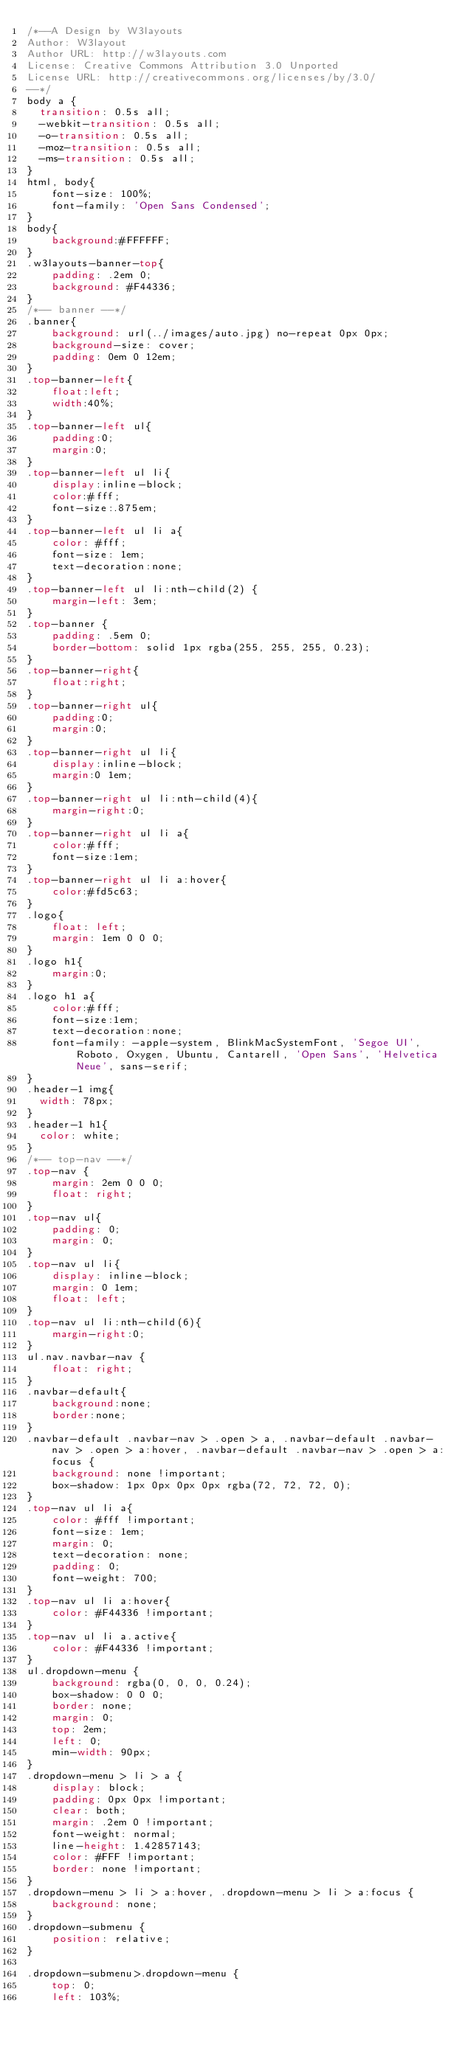Convert code to text. <code><loc_0><loc_0><loc_500><loc_500><_CSS_>/*--A Design by W3layouts 
Author: W3layout
Author URL: http://w3layouts.com
License: Creative Commons Attribution 3.0 Unported
License URL: http://creativecommons.org/licenses/by/3.0/
--*/
body a {
  transition: 0.5s all;
  -webkit-transition: 0.5s all;
  -o-transition: 0.5s all;
  -moz-transition: 0.5s all;
  -ms-transition: 0.5s all;
}
html, body{
    font-size: 100%;
	font-family: 'Open Sans Condensed';
}
body{
	background:#FFFFFF;
}
.w3layouts-banner-top{
    padding: .2em 0;
    background: #F44336;
}
/*-- banner --*/
.banner{
    background: url(../images/auto.jpg) no-repeat 0px 0px;
    background-size: cover;
    padding: 0em 0 12em;
}
.top-banner-left{
	float:left;
	width:40%;
}
.top-banner-left ul{
	padding:0;
	margin:0;
}
.top-banner-left ul li{
	display:inline-block;
	color:#fff;
	font-size:.875em;
}
.top-banner-left ul li a{
    color: #fff;
    font-size: 1em;
	text-decoration:none;
}
.top-banner-left ul li:nth-child(2) {
    margin-left: 3em;
}
.top-banner {
    padding: .5em 0;
    border-bottom: solid 1px rgba(255, 255, 255, 0.23);
}
.top-banner-right{
	float:right;
}
.top-banner-right ul{
	padding:0;
	margin:0;
}
.top-banner-right ul li{
	display:inline-block;
	margin:0 1em;
}
.top-banner-right ul li:nth-child(4){
	margin-right:0;
}
.top-banner-right ul li a{
	color:#fff;
	font-size:1em;
}
.top-banner-right ul li a:hover{
	color:#fd5c63;
}
.logo{
    float: left;
    margin: 1em 0 0 0;
}
.logo h1{
	margin:0;
}
.logo h1 a{
	color:#fff;
	font-size:1em;
	text-decoration:none;
	font-family: -apple-system, BlinkMacSystemFont, 'Segoe UI', Roboto, Oxygen, Ubuntu, Cantarell, 'Open Sans', 'Helvetica Neue', sans-serif;
}
.header-1 img{
  width: 78px;
}
.header-1 h1{
  color: white;
}
/*-- top-nav --*/
.top-nav {
    margin: 2em 0 0 0;
	float: right;
}
.top-nav ul{
    padding: 0;
    margin: 0;
}
.top-nav ul li{
    display: inline-block;
    margin: 0 1em;
    float: left;
}
.top-nav ul li:nth-child(6){
	margin-right:0;
}
ul.nav.navbar-nav {
    float: right;
}
.navbar-default{
	background:none;
	border:none;
}
.navbar-default .navbar-nav > .open > a, .navbar-default .navbar-nav > .open > a:hover, .navbar-default .navbar-nav > .open > a:focus {
    background: none !important;
    box-shadow: 1px 0px 0px 0px rgba(72, 72, 72, 0);
}
.top-nav ul li a{
    color: #fff !important;
    font-size: 1em;
    margin: 0;
    text-decoration: none;
    padding: 0;
    font-weight: 700;
}
.top-nav ul li a:hover{
    color: #F44336 !important;
}
.top-nav ul li a.active{
    color: #F44336 !important;
}
ul.dropdown-menu {
    background: rgba(0, 0, 0, 0.24);
    box-shadow: 0 0 0;
    border: none;
    margin: 0;
    top: 2em;
    left: 0;
    min-width: 90px;
}
.dropdown-menu > li > a {
    display: block;
    padding: 0px 0px !important;
    clear: both;
    margin: .2em 0 !important;
    font-weight: normal;
    line-height: 1.42857143;
    color: #FFF !important;
    border: none !important;
}
.dropdown-menu > li > a:hover, .dropdown-menu > li > a:focus {
    background: none;
}
.dropdown-submenu {
    position: relative;
}

.dropdown-submenu>.dropdown-menu {
    top: 0;
    left: 103%;</code> 